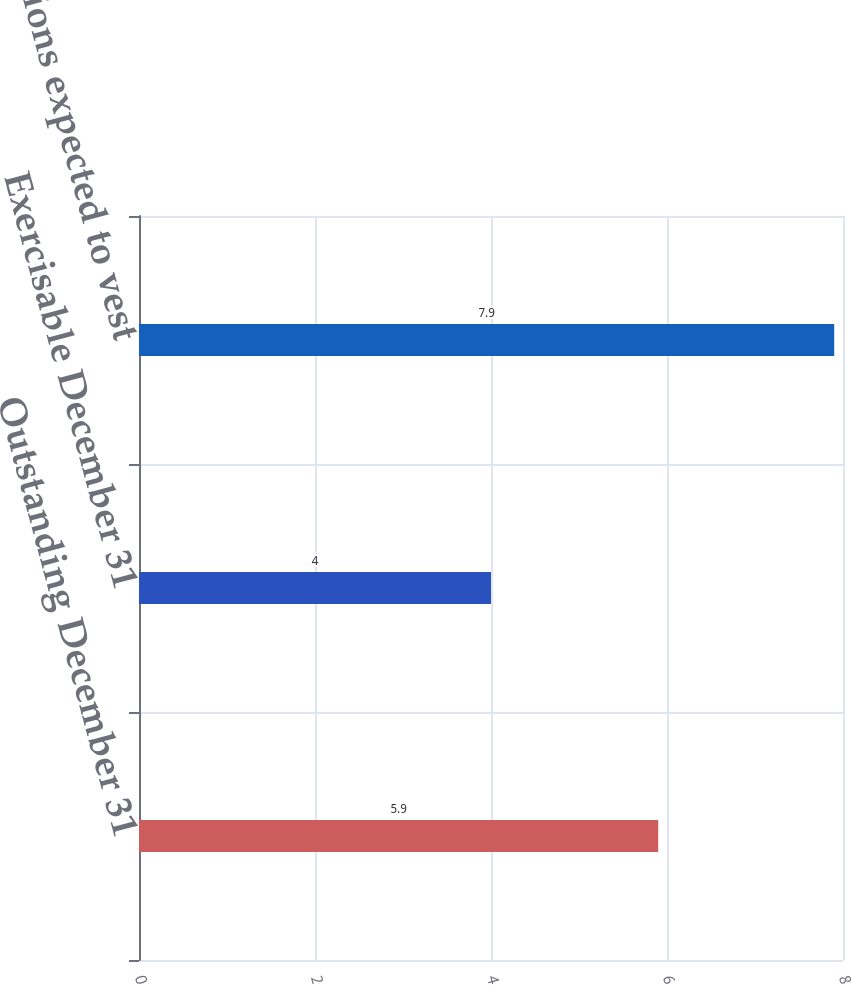Convert chart to OTSL. <chart><loc_0><loc_0><loc_500><loc_500><bar_chart><fcel>Outstanding December 31<fcel>Exercisable December 31<fcel>Options expected to vest<nl><fcel>5.9<fcel>4<fcel>7.9<nl></chart> 